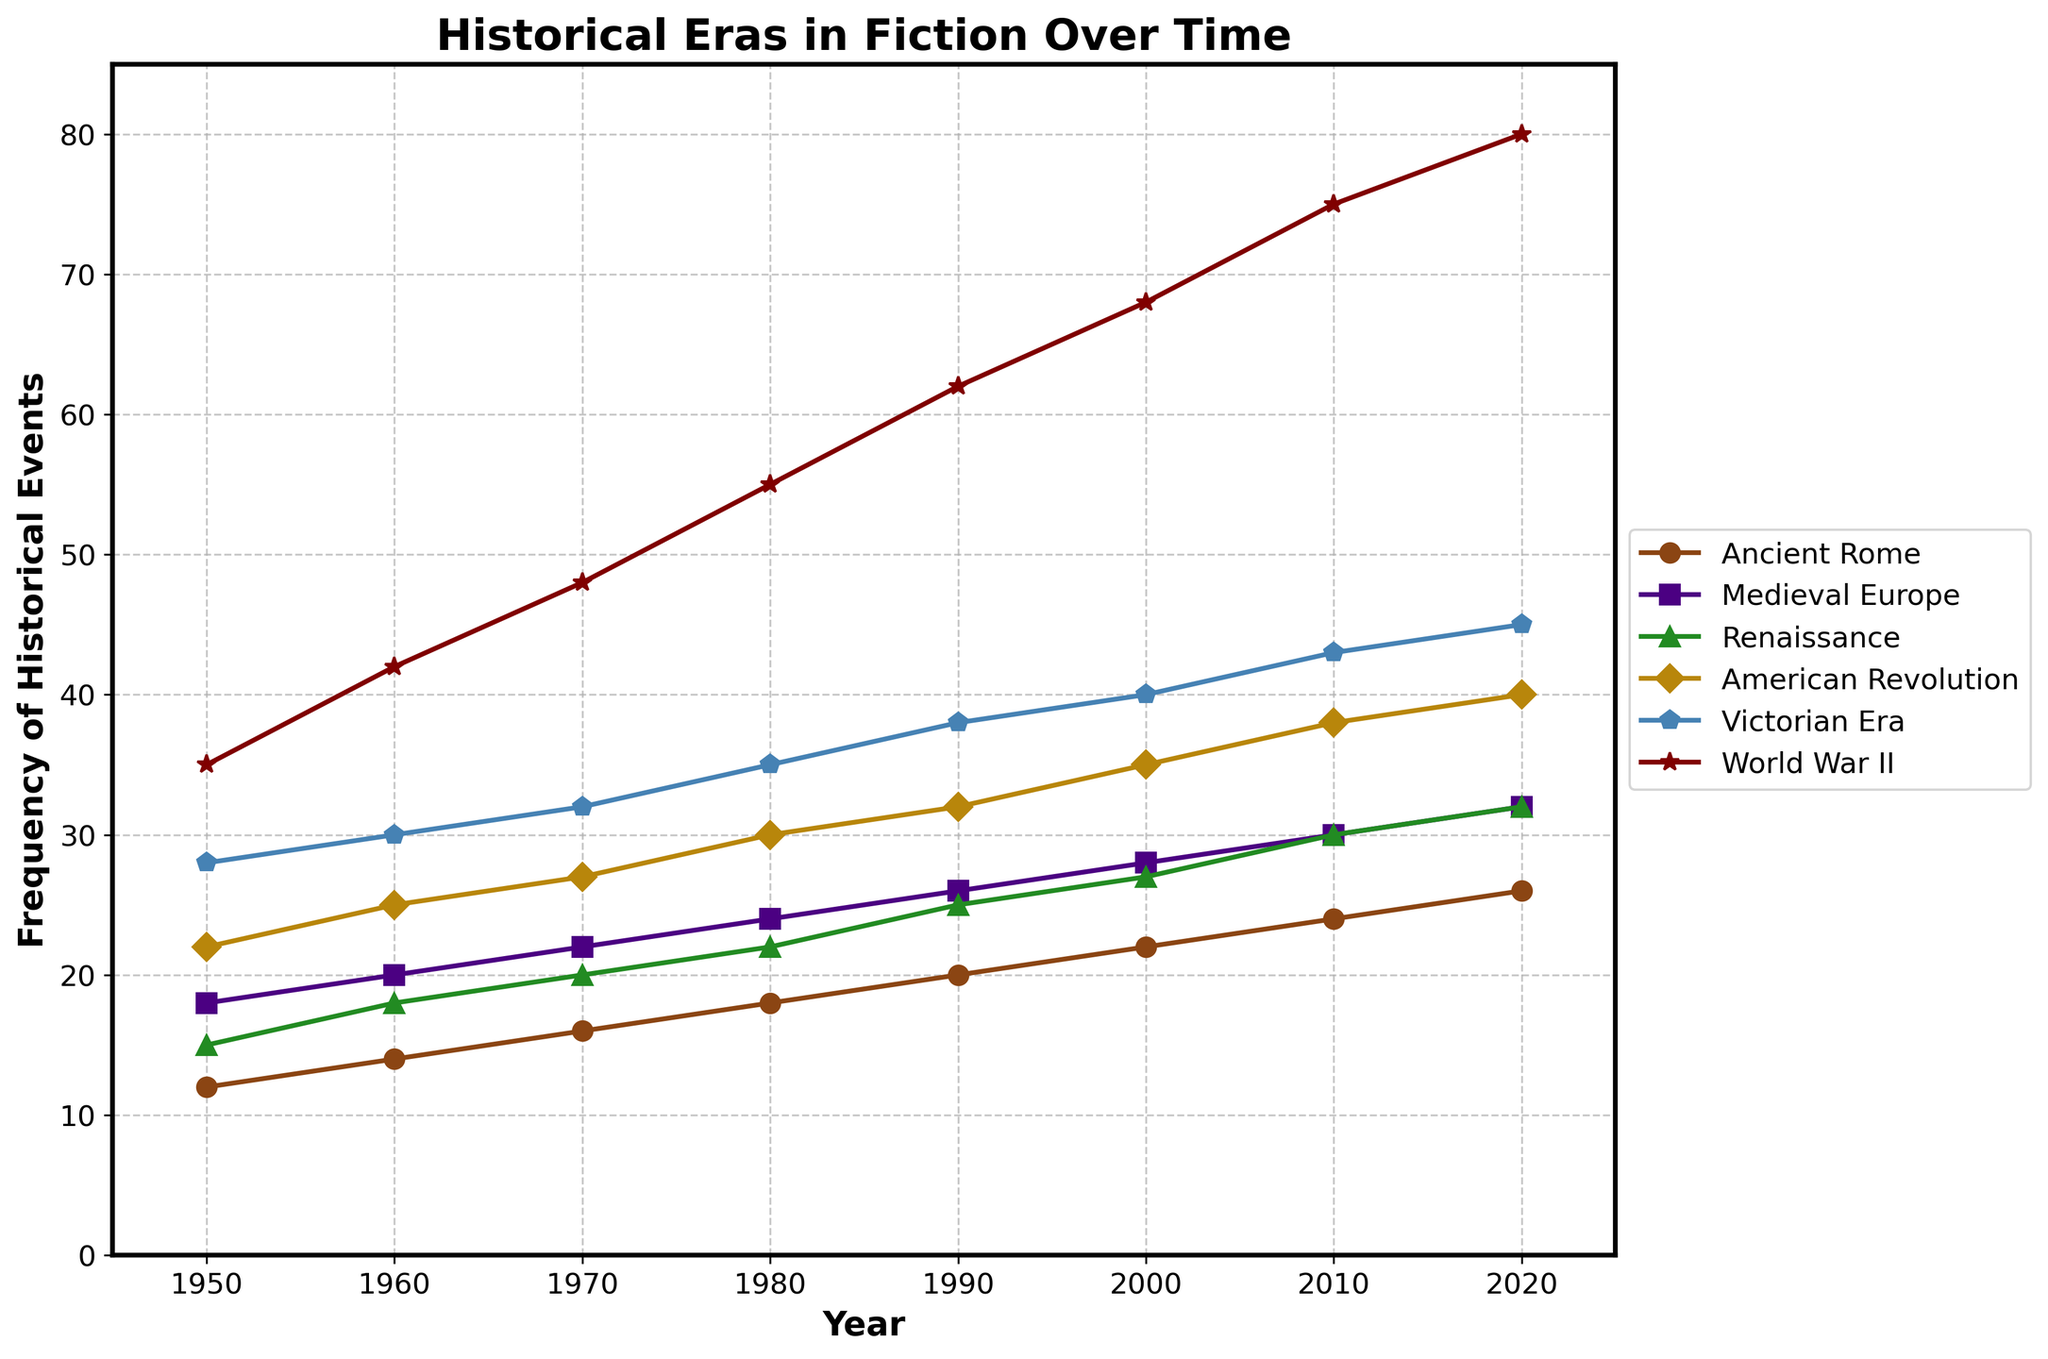What era shows the highest frequency in 1950? In 1950, the highest line on the chart represents "World War II" with a frequency value of 35.
Answer: World War II Between 1960 and 1980, which era saw the largest increase in frequency? To find the largest increase, examine the frequency values for each era in 1960 and 1980. Calculate the differences: Ancient Rome (18-14), Medieval Europe (24-20), Renaissance (22-18), American Revolution (30-25), Victorian Era (35-30), World War II (55-42). World War II has the largest increase of 13.
Answer: World War II By how much did the frequency of Victorian Era events increase from 1950 to 2020? Subtract the 1950 value from the 2020 value for the Victorian Era: 45 - 28 = 17.
Answer: 17 What is the average frequency of American Revolution events across all years? Add the frequency values for American Revolution from 1950 to 2020: 22 + 25 + 27 + 30 + 32 + 35 + 38 + 40 = 249. Divide by the number of years (8): 249 / 8 = 31.125.
Answer: 31.125 Which era had the least frequency in 2020? In 2020, the lowest line on the chart represents "Ancient Rome" with a frequency value of 26.
Answer: Ancient Rome From 2000 to 2010, which era shows the smallest increase in frequency? Calculate the difference for each era: Ancient Rome (24-22), Medieval Europe (30-28), Renaissance (30-27), American Revolution (38-35), Victorian Era (43-40), World War II (75-68). The smallest increase is 2 for Medieval Europe.
Answer: Medieval Europe What is the frequency difference between Ancient Rome and World War II in 1980? Subtract the frequency of Ancient Rome from World War II in 1980: 55 - 18 = 37.
Answer: 37 Between 1950 and 2020, did the frequency of Renaissance events ever surpass the frequency of Victorian Era events? Examine the chart: The Renaissance frequency remains lower than the Victorian Era frequency across all years from 1950 to 2020.
Answer: No During which decade did the frequency of Medieval Europe reach 30? Examine the chart: The frequency for Medieval Europe reaches 30 in the year 2010. This falls within the decade 2010s.
Answer: 2010s 